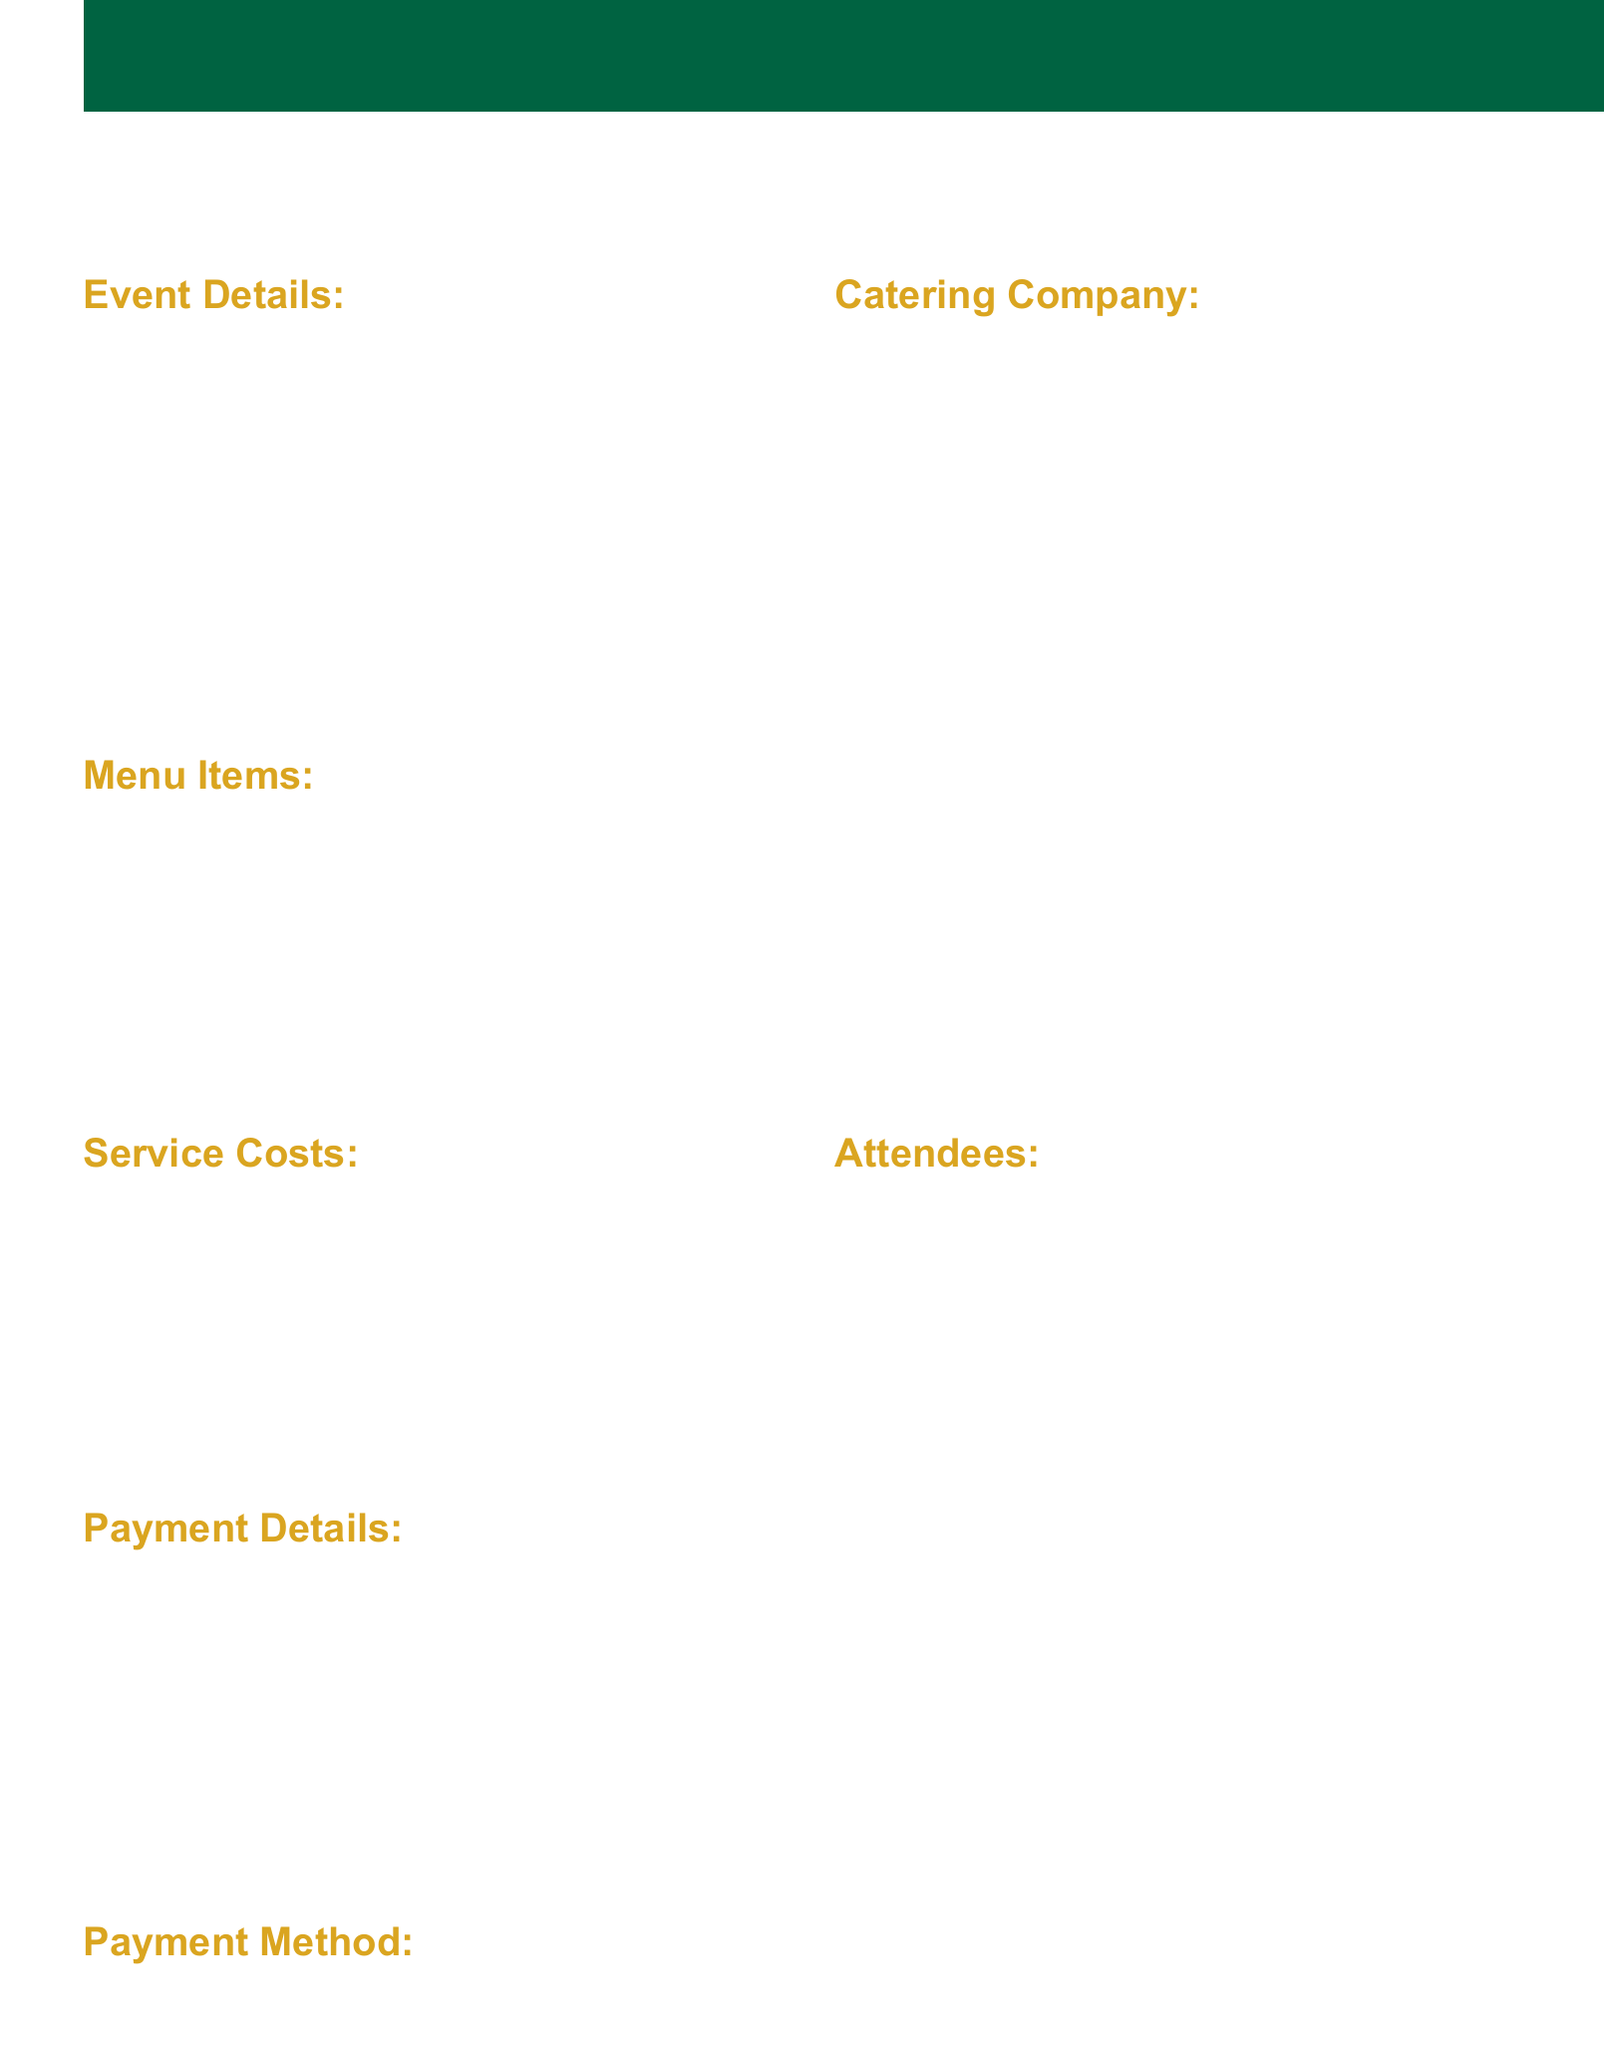What is the date of the event? The date of the event is specified in the document under event details.
Answer: April 15, 2023 Who is the contact person for the catering company? The contact person for Halal Delights Catering is mentioned in the catering company section.
Answer: Ahmed Khan What is the total amount due for the catering services? The total amount due is calculated in the payment details section at the end of the document.
Answer: 120750 How many attendees were expected? The expected number of attendees is indicated in the attendees section of the document.
Answer: 200 What method of payment was used? The payment method section specifies the method used for payment.
Answer: Bank Transfer What is one of the additional notes regarding food? The additional notes provide various details about the catering services, one of which can be identified.
Answer: All food prepared according to Halal standards What was the overall satisfaction rating from community feedback? The overall satisfaction rating is provided under the community feedback section of the document.
Answer: 4.8 How many actual attendees were there? The actual count of attendees is provided in the attendees section.
Answer: 185 What is the food cost listed in the service costs? The food cost is specified in the service costs section of the document.
Answer: 75000 